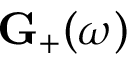<formula> <loc_0><loc_0><loc_500><loc_500>G _ { + } ( \omega )</formula> 